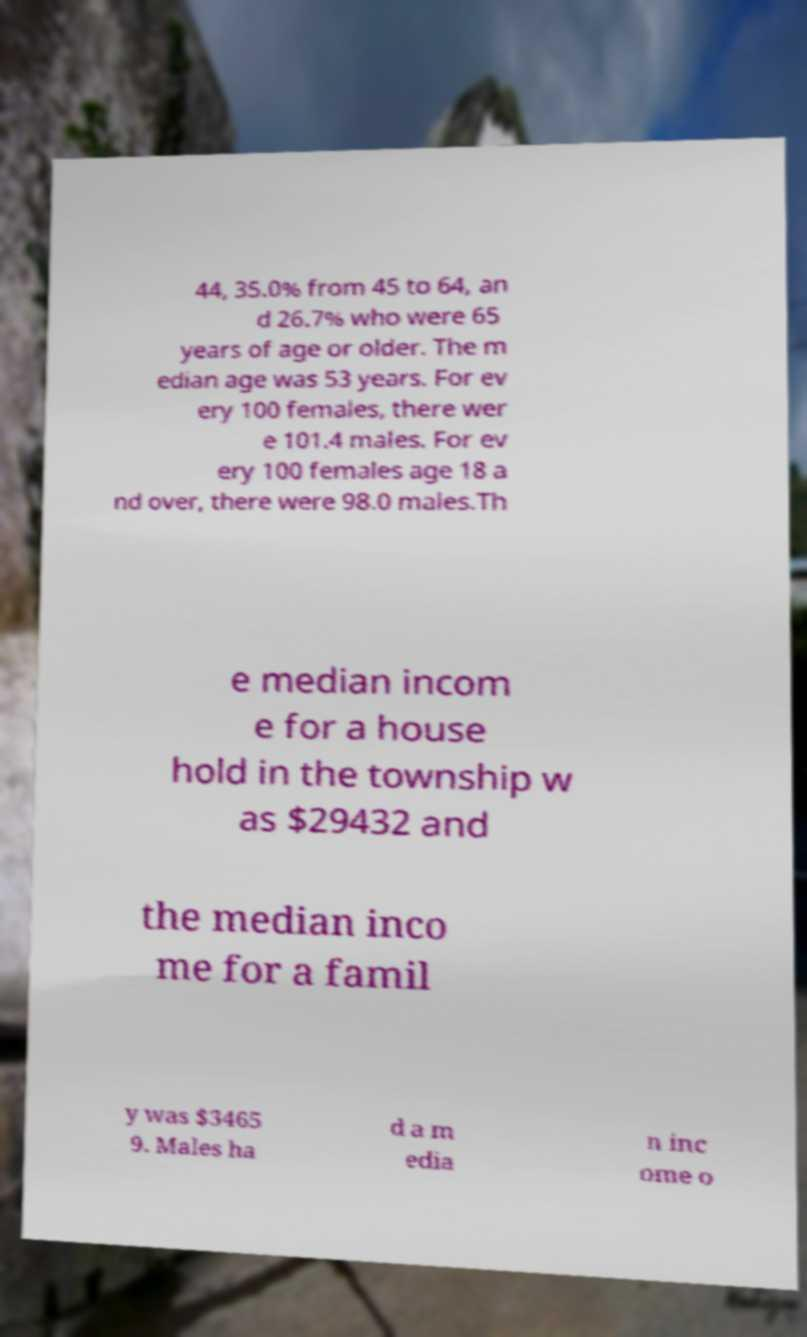Can you read and provide the text displayed in the image?This photo seems to have some interesting text. Can you extract and type it out for me? 44, 35.0% from 45 to 64, an d 26.7% who were 65 years of age or older. The m edian age was 53 years. For ev ery 100 females, there wer e 101.4 males. For ev ery 100 females age 18 a nd over, there were 98.0 males.Th e median incom e for a house hold in the township w as $29432 and the median inco me for a famil y was $3465 9. Males ha d a m edia n inc ome o 